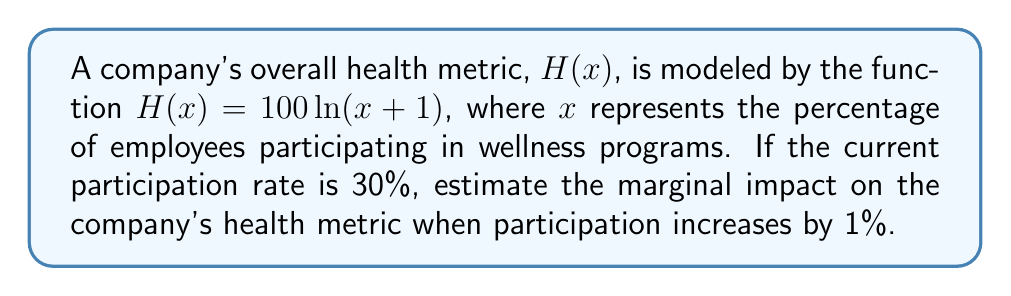Can you answer this question? To estimate the marginal impact, we need to find the derivative of the health metric function and evaluate it at the current participation rate.

Step 1: Find the derivative of $H(x)$
$$\frac{d}{dx}H(x) = \frac{d}{dx}[100 \ln(x+1)] = \frac{100}{x+1}$$

Step 2: Evaluate the derivative at $x = 30$ (current participation rate)
$$H'(30) = \frac{100}{30+1} = \frac{100}{31} \approx 3.226$$

Step 3: Interpret the result
The derivative value of approximately 3.226 represents the instantaneous rate of change in the health metric when the participation rate is 30%. This means that for a small increase in participation, we can expect the health metric to increase by about 3.226 units per percentage point of participation.

Step 4: Estimate the impact of a 1% increase
Since we're asked about a 1% increase, we can multiply the derivative value by 1:
$$3.226 \times 1 = 3.226$$

This suggests that when the participation rate increases from 30% to 31%, we can expect the company's health metric to increase by approximately 3.226 units.
Answer: $3.226$ units 